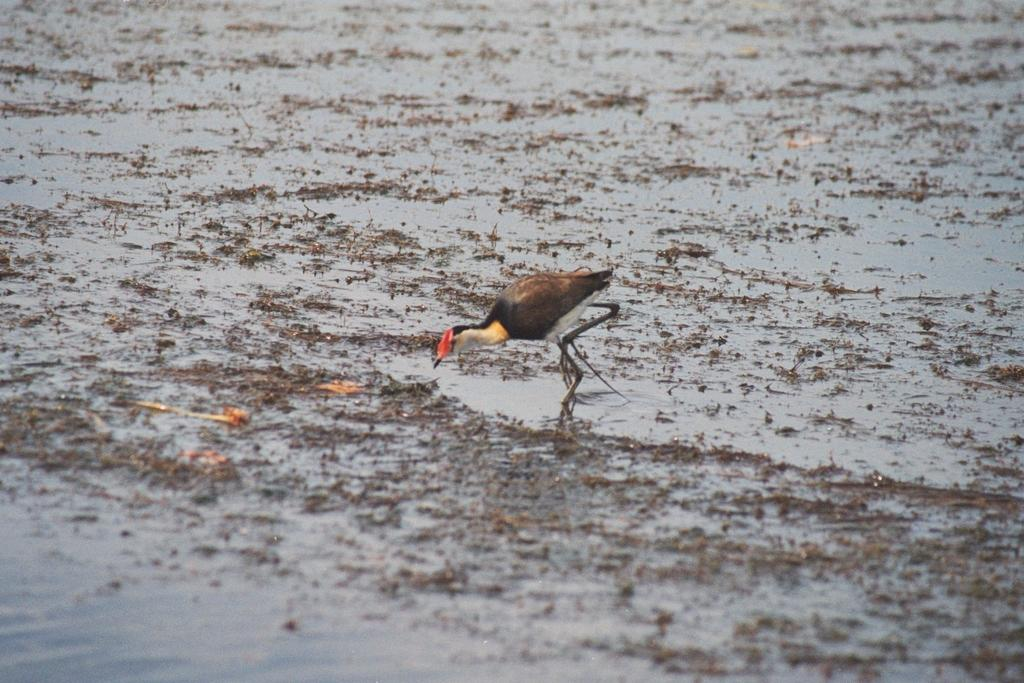What type of animal can be seen in the image? There is a bird in the image. Where is the bird located in the image? The bird is standing in the water. What type of chair is the bird sitting on in the image? There is no chair present in the image; the bird is standing in the water. 